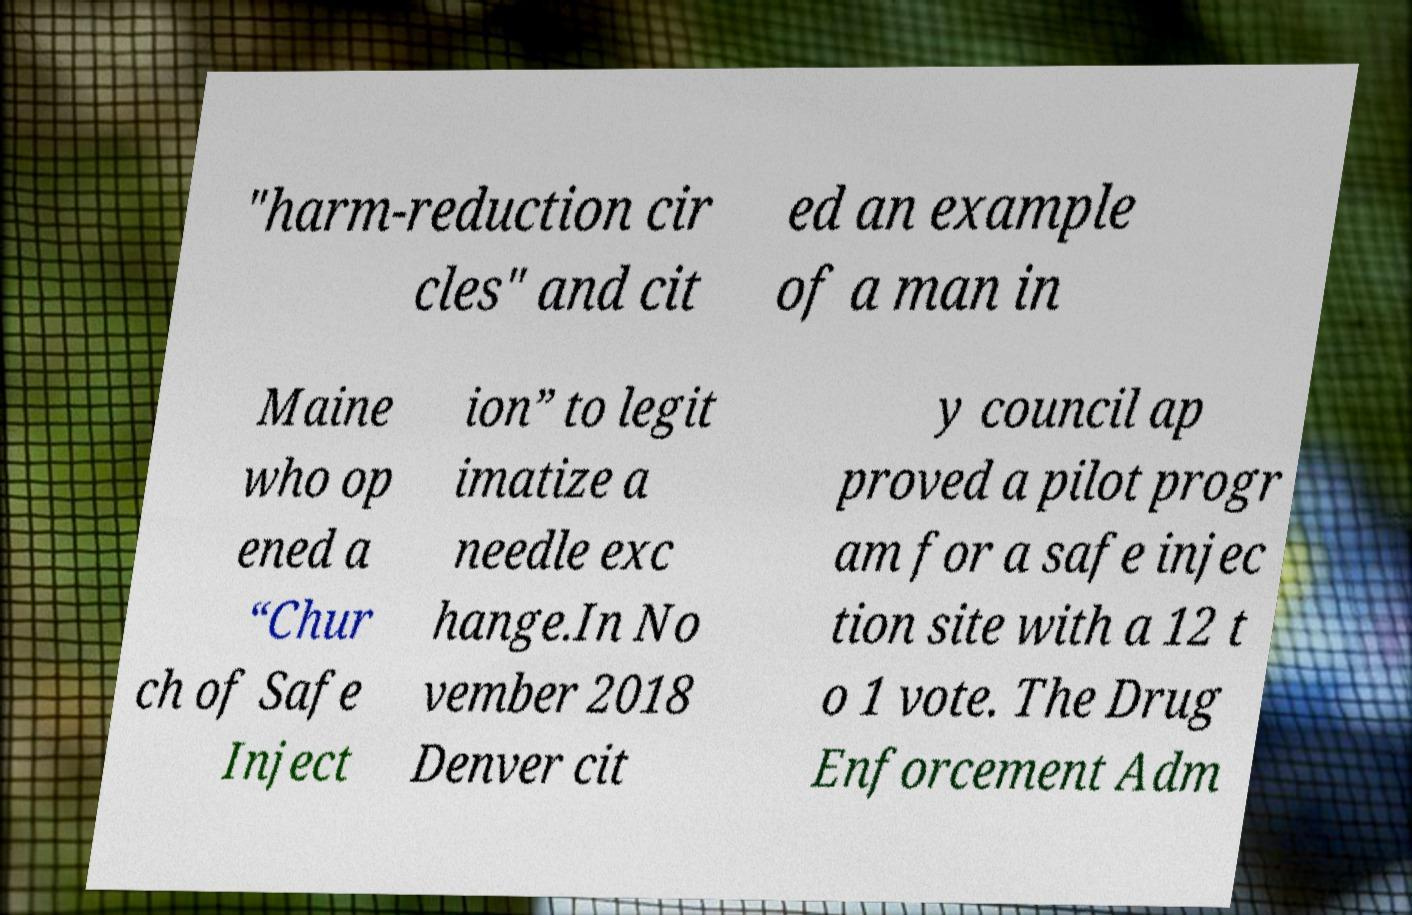There's text embedded in this image that I need extracted. Can you transcribe it verbatim? "harm-reduction cir cles" and cit ed an example of a man in Maine who op ened a “Chur ch of Safe Inject ion” to legit imatize a needle exc hange.In No vember 2018 Denver cit y council ap proved a pilot progr am for a safe injec tion site with a 12 t o 1 vote. The Drug Enforcement Adm 